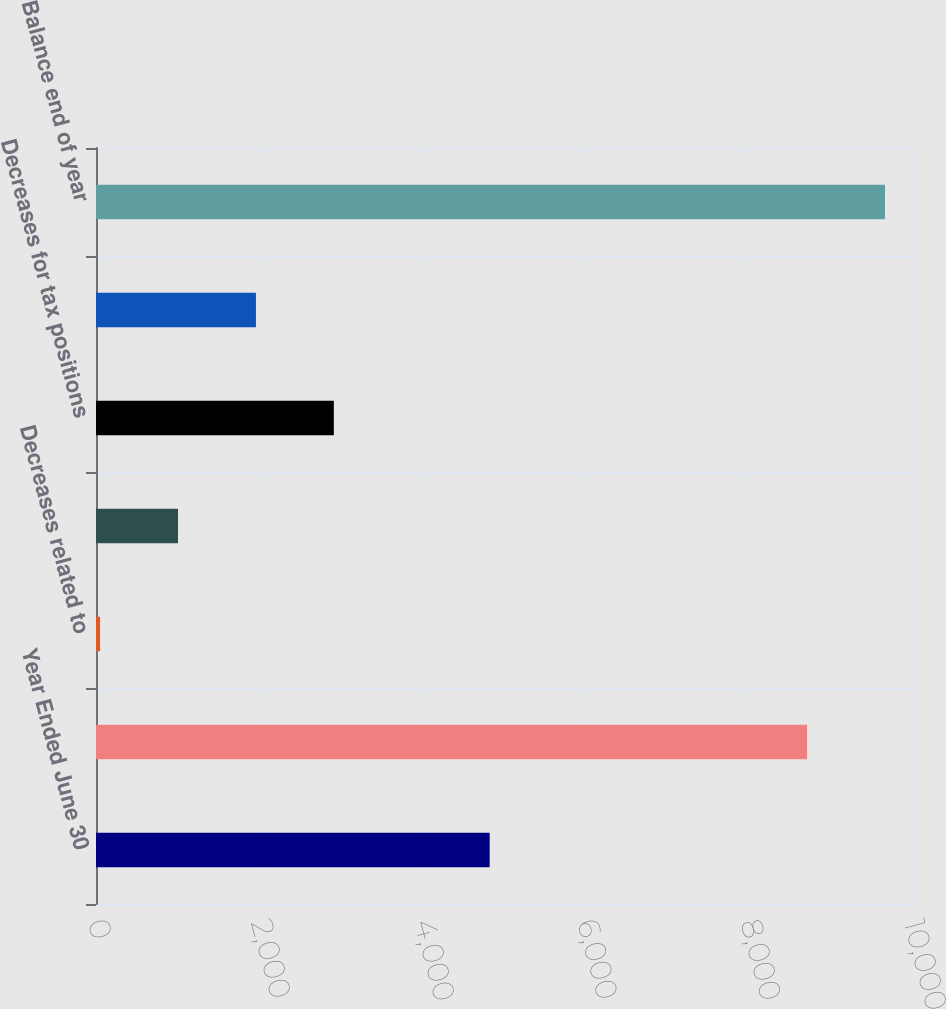Convert chart to OTSL. <chart><loc_0><loc_0><loc_500><loc_500><bar_chart><fcel>Year Ended June 30<fcel>Balance beginning of year<fcel>Decreases related to<fcel>Increases for tax positions<fcel>Decreases for tax positions<fcel>Decreases due to lapsed<fcel>Balance end of year<nl><fcel>4824.5<fcel>8714<fcel>50<fcel>1004.9<fcel>2914.7<fcel>1959.8<fcel>9668.9<nl></chart> 